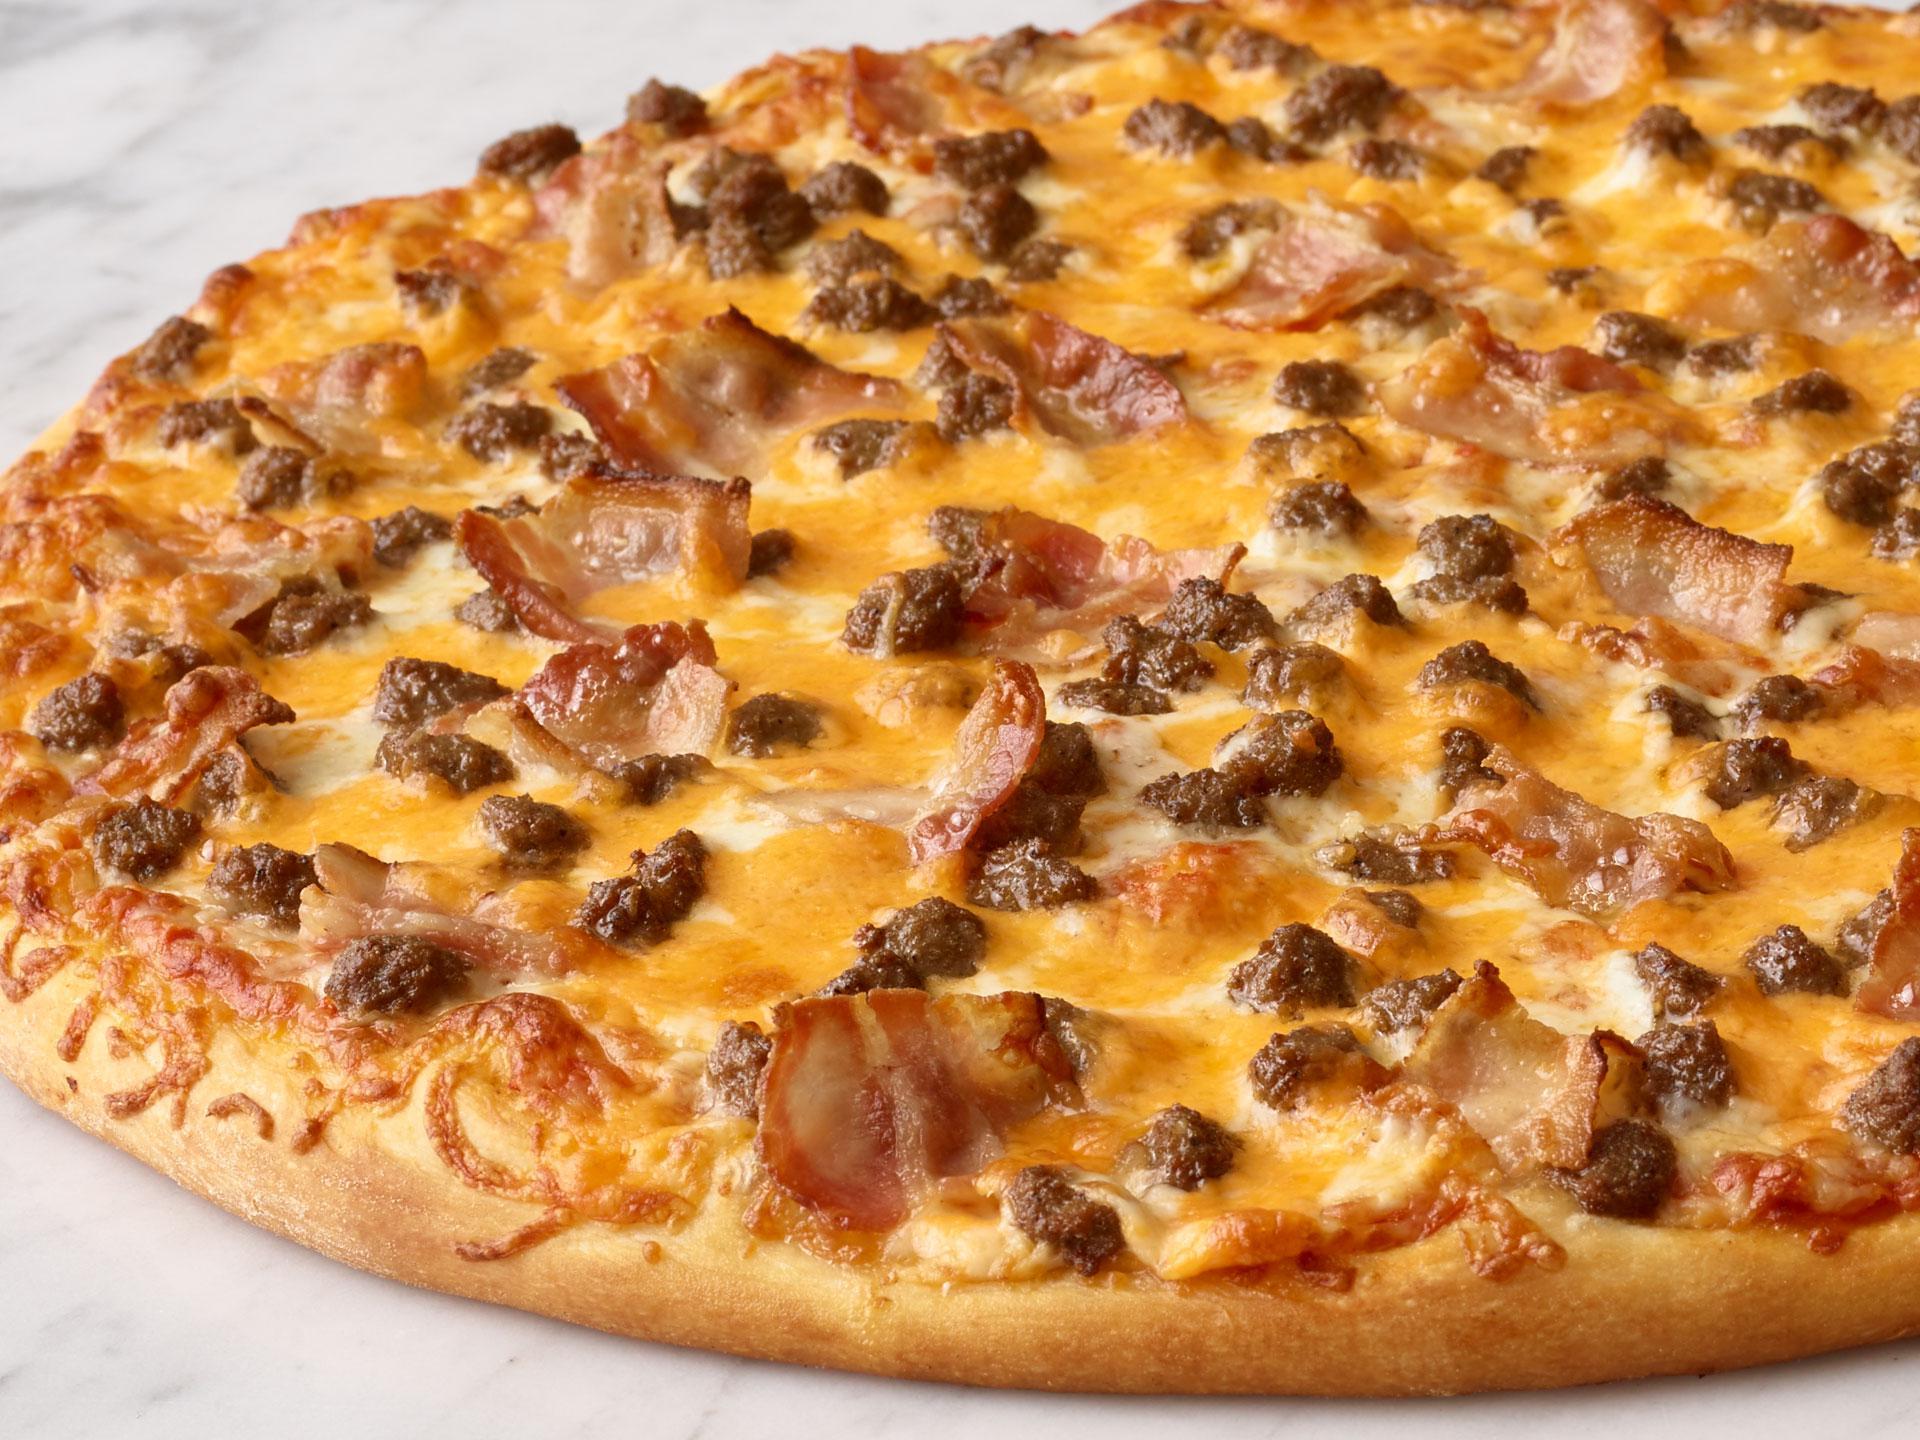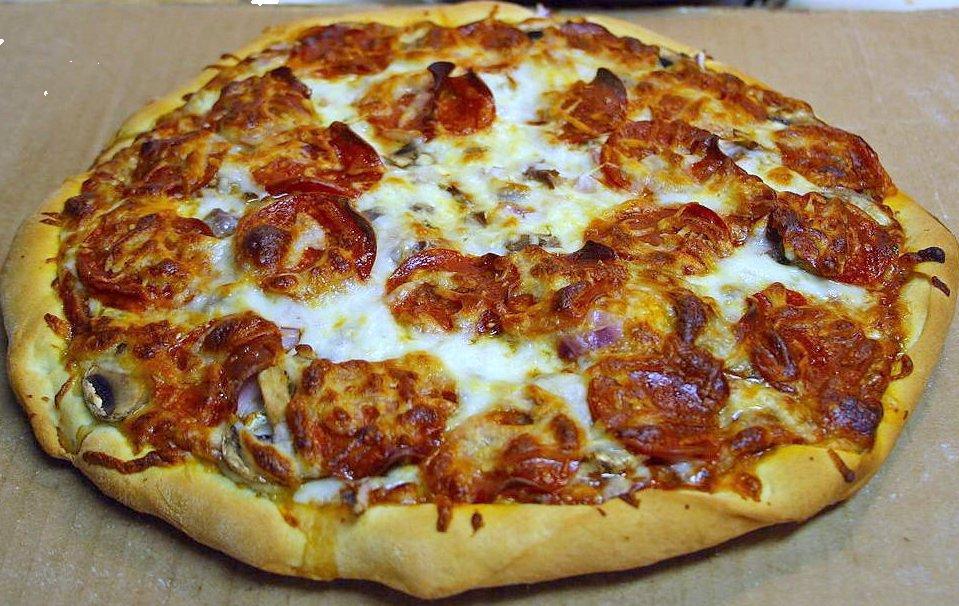The first image is the image on the left, the second image is the image on the right. Examine the images to the left and right. Is the description "There are two circle pizzas." accurate? Answer yes or no. Yes. 